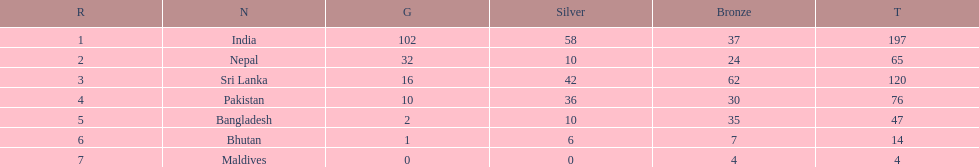How many more gold medals has nepal won than pakistan? 22. 